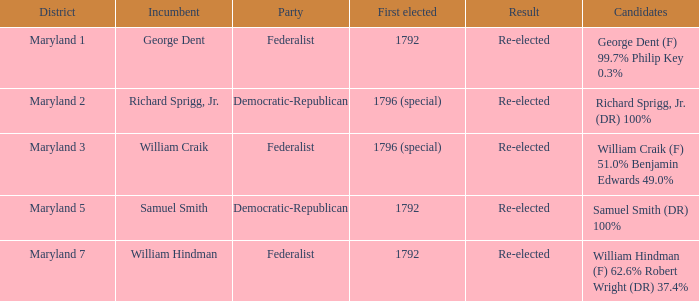What is the party when the incumbent is samuel smith? Democratic-Republican. 